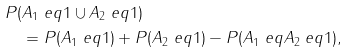Convert formula to latex. <formula><loc_0><loc_0><loc_500><loc_500>& P ( A _ { 1 } \ e q 1 \cup A _ { 2 } \ e q 1 ) \\ & \quad = P ( A _ { 1 } \ e q 1 ) + P ( A _ { 2 } \ e q 1 ) - P ( A _ { 1 } \ e q A _ { 2 } \ e q 1 ) ,</formula> 